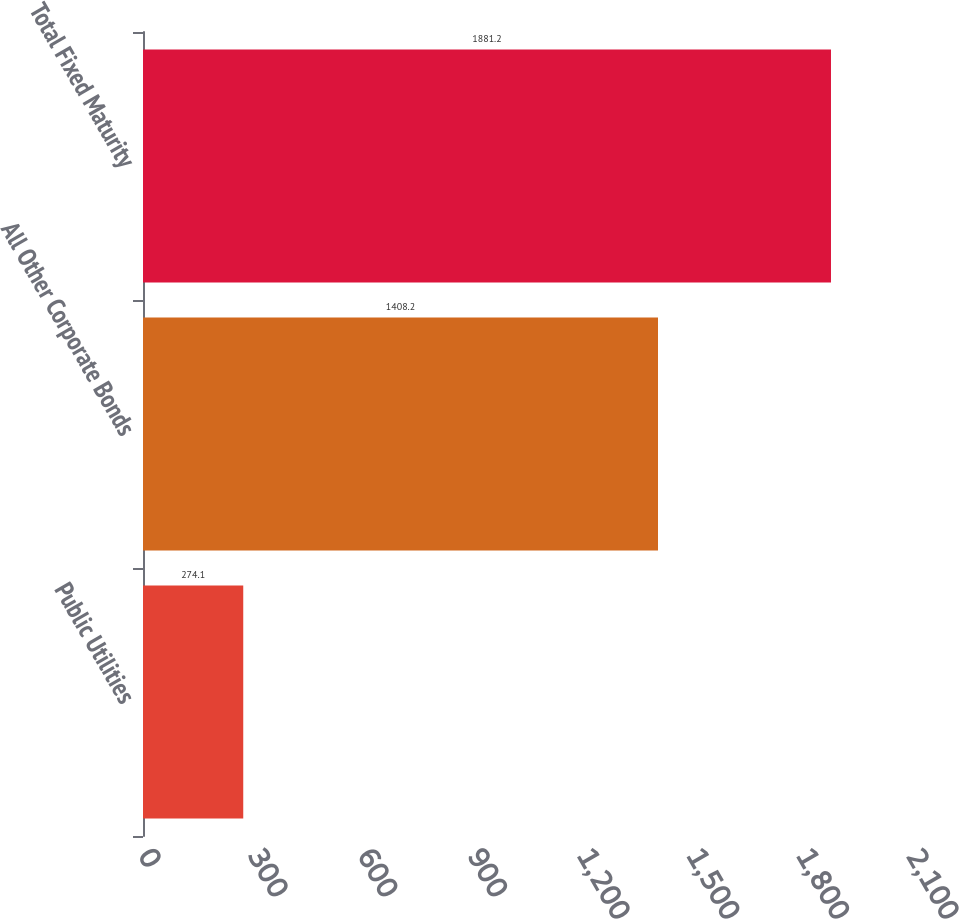<chart> <loc_0><loc_0><loc_500><loc_500><bar_chart><fcel>Public Utilities<fcel>All Other Corporate Bonds<fcel>Total Fixed Maturity<nl><fcel>274.1<fcel>1408.2<fcel>1881.2<nl></chart> 